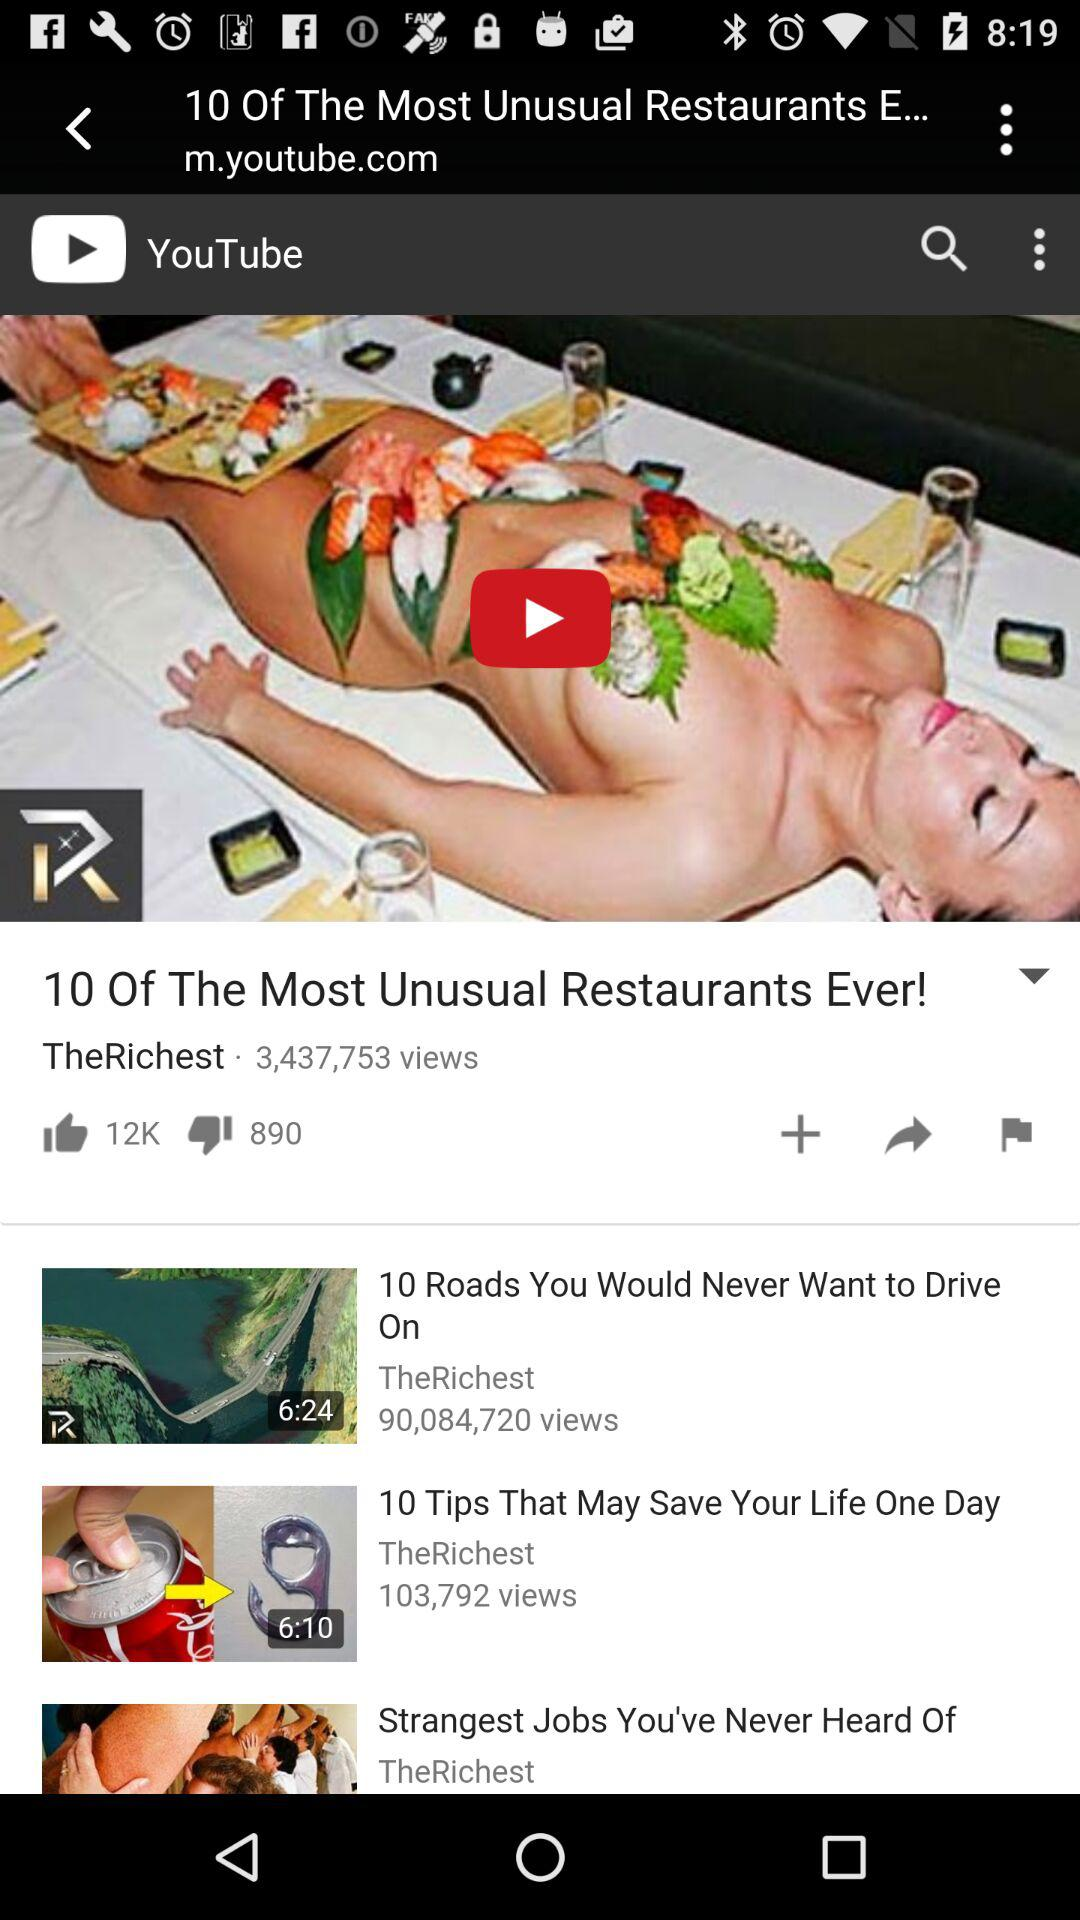How many times has the "10 Of The Most Unusual Restaurants Ever!" video been viewed? The "10 Of The Most Unusual Restaurants Ever!" video has been viewed 3,437,753 times. 